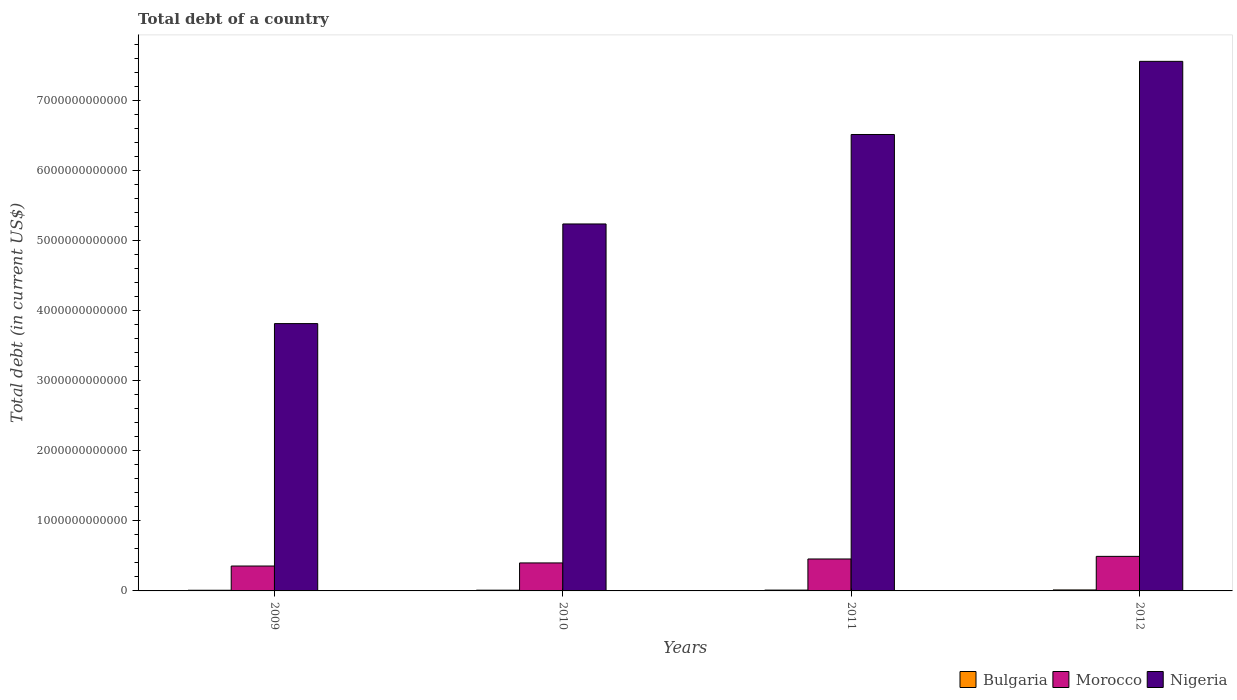How many different coloured bars are there?
Your answer should be very brief. 3. Are the number of bars on each tick of the X-axis equal?
Keep it short and to the point. Yes. How many bars are there on the 3rd tick from the left?
Your answer should be very brief. 3. How many bars are there on the 1st tick from the right?
Give a very brief answer. 3. In how many cases, is the number of bars for a given year not equal to the number of legend labels?
Ensure brevity in your answer.  0. What is the debt in Nigeria in 2012?
Keep it short and to the point. 7.56e+12. Across all years, what is the maximum debt in Morocco?
Offer a terse response. 4.94e+11. Across all years, what is the minimum debt in Morocco?
Your response must be concise. 3.56e+11. In which year was the debt in Bulgaria maximum?
Your answer should be very brief. 2012. What is the total debt in Morocco in the graph?
Provide a succinct answer. 1.71e+12. What is the difference between the debt in Nigeria in 2009 and that in 2011?
Ensure brevity in your answer.  -2.70e+12. What is the difference between the debt in Nigeria in 2010 and the debt in Bulgaria in 2009?
Your answer should be very brief. 5.23e+12. What is the average debt in Morocco per year?
Your answer should be compact. 4.26e+11. In the year 2010, what is the difference between the debt in Nigeria and debt in Morocco?
Give a very brief answer. 4.84e+12. What is the ratio of the debt in Bulgaria in 2011 to that in 2012?
Give a very brief answer. 0.83. What is the difference between the highest and the second highest debt in Bulgaria?
Provide a succinct answer. 2.40e+09. What is the difference between the highest and the lowest debt in Morocco?
Offer a very short reply. 1.38e+11. Is the sum of the debt in Morocco in 2009 and 2012 greater than the maximum debt in Nigeria across all years?
Provide a short and direct response. No. What does the 2nd bar from the left in 2009 represents?
Offer a very short reply. Morocco. How many bars are there?
Make the answer very short. 12. Are all the bars in the graph horizontal?
Your answer should be compact. No. How many years are there in the graph?
Keep it short and to the point. 4. What is the difference between two consecutive major ticks on the Y-axis?
Provide a succinct answer. 1.00e+12. Are the values on the major ticks of Y-axis written in scientific E-notation?
Your answer should be very brief. No. Does the graph contain any zero values?
Offer a terse response. No. Does the graph contain grids?
Keep it short and to the point. No. Where does the legend appear in the graph?
Your response must be concise. Bottom right. How many legend labels are there?
Provide a short and direct response. 3. What is the title of the graph?
Your answer should be very brief. Total debt of a country. Does "Mauritius" appear as one of the legend labels in the graph?
Keep it short and to the point. No. What is the label or title of the X-axis?
Provide a short and direct response. Years. What is the label or title of the Y-axis?
Your answer should be compact. Total debt (in current US$). What is the Total debt (in current US$) of Bulgaria in 2009?
Provide a succinct answer. 9.44e+09. What is the Total debt (in current US$) in Morocco in 2009?
Your answer should be compact. 3.56e+11. What is the Total debt (in current US$) in Nigeria in 2009?
Offer a very short reply. 3.82e+12. What is the Total debt (in current US$) in Bulgaria in 2010?
Ensure brevity in your answer.  1.05e+1. What is the Total debt (in current US$) of Morocco in 2010?
Keep it short and to the point. 4.00e+11. What is the Total debt (in current US$) of Nigeria in 2010?
Your answer should be compact. 5.24e+12. What is the Total debt (in current US$) in Bulgaria in 2011?
Give a very brief answer. 1.16e+1. What is the Total debt (in current US$) in Morocco in 2011?
Keep it short and to the point. 4.56e+11. What is the Total debt (in current US$) of Nigeria in 2011?
Provide a short and direct response. 6.52e+12. What is the Total debt (in current US$) of Bulgaria in 2012?
Provide a short and direct response. 1.40e+1. What is the Total debt (in current US$) in Morocco in 2012?
Your answer should be compact. 4.94e+11. What is the Total debt (in current US$) of Nigeria in 2012?
Keep it short and to the point. 7.56e+12. Across all years, what is the maximum Total debt (in current US$) of Bulgaria?
Provide a short and direct response. 1.40e+1. Across all years, what is the maximum Total debt (in current US$) in Morocco?
Your answer should be very brief. 4.94e+11. Across all years, what is the maximum Total debt (in current US$) of Nigeria?
Ensure brevity in your answer.  7.56e+12. Across all years, what is the minimum Total debt (in current US$) in Bulgaria?
Offer a terse response. 9.44e+09. Across all years, what is the minimum Total debt (in current US$) of Morocco?
Your response must be concise. 3.56e+11. Across all years, what is the minimum Total debt (in current US$) of Nigeria?
Your response must be concise. 3.82e+12. What is the total Total debt (in current US$) in Bulgaria in the graph?
Your response must be concise. 4.56e+1. What is the total Total debt (in current US$) in Morocco in the graph?
Keep it short and to the point. 1.71e+12. What is the total Total debt (in current US$) of Nigeria in the graph?
Offer a terse response. 2.31e+13. What is the difference between the Total debt (in current US$) of Bulgaria in 2009 and that in 2010?
Your answer should be compact. -1.09e+09. What is the difference between the Total debt (in current US$) in Morocco in 2009 and that in 2010?
Keep it short and to the point. -4.43e+1. What is the difference between the Total debt (in current US$) of Nigeria in 2009 and that in 2010?
Your answer should be compact. -1.42e+12. What is the difference between the Total debt (in current US$) in Bulgaria in 2009 and that in 2011?
Your response must be concise. -2.19e+09. What is the difference between the Total debt (in current US$) of Morocco in 2009 and that in 2011?
Provide a short and direct response. -1.01e+11. What is the difference between the Total debt (in current US$) in Nigeria in 2009 and that in 2011?
Your answer should be very brief. -2.70e+12. What is the difference between the Total debt (in current US$) of Bulgaria in 2009 and that in 2012?
Offer a terse response. -4.58e+09. What is the difference between the Total debt (in current US$) in Morocco in 2009 and that in 2012?
Make the answer very short. -1.38e+11. What is the difference between the Total debt (in current US$) in Nigeria in 2009 and that in 2012?
Keep it short and to the point. -3.75e+12. What is the difference between the Total debt (in current US$) in Bulgaria in 2010 and that in 2011?
Your answer should be compact. -1.10e+09. What is the difference between the Total debt (in current US$) of Morocco in 2010 and that in 2011?
Your answer should be compact. -5.63e+1. What is the difference between the Total debt (in current US$) in Nigeria in 2010 and that in 2011?
Provide a short and direct response. -1.28e+12. What is the difference between the Total debt (in current US$) of Bulgaria in 2010 and that in 2012?
Your response must be concise. -3.49e+09. What is the difference between the Total debt (in current US$) in Morocco in 2010 and that in 2012?
Your answer should be compact. -9.38e+1. What is the difference between the Total debt (in current US$) of Nigeria in 2010 and that in 2012?
Offer a terse response. -2.32e+12. What is the difference between the Total debt (in current US$) in Bulgaria in 2011 and that in 2012?
Offer a very short reply. -2.40e+09. What is the difference between the Total debt (in current US$) of Morocco in 2011 and that in 2012?
Your answer should be very brief. -3.75e+1. What is the difference between the Total debt (in current US$) of Nigeria in 2011 and that in 2012?
Your answer should be compact. -1.04e+12. What is the difference between the Total debt (in current US$) of Bulgaria in 2009 and the Total debt (in current US$) of Morocco in 2010?
Your answer should be compact. -3.90e+11. What is the difference between the Total debt (in current US$) in Bulgaria in 2009 and the Total debt (in current US$) in Nigeria in 2010?
Offer a terse response. -5.23e+12. What is the difference between the Total debt (in current US$) in Morocco in 2009 and the Total debt (in current US$) in Nigeria in 2010?
Your response must be concise. -4.89e+12. What is the difference between the Total debt (in current US$) in Bulgaria in 2009 and the Total debt (in current US$) in Morocco in 2011?
Offer a very short reply. -4.47e+11. What is the difference between the Total debt (in current US$) in Bulgaria in 2009 and the Total debt (in current US$) in Nigeria in 2011?
Ensure brevity in your answer.  -6.51e+12. What is the difference between the Total debt (in current US$) of Morocco in 2009 and the Total debt (in current US$) of Nigeria in 2011?
Offer a very short reply. -6.16e+12. What is the difference between the Total debt (in current US$) of Bulgaria in 2009 and the Total debt (in current US$) of Morocco in 2012?
Make the answer very short. -4.84e+11. What is the difference between the Total debt (in current US$) of Bulgaria in 2009 and the Total debt (in current US$) of Nigeria in 2012?
Provide a succinct answer. -7.55e+12. What is the difference between the Total debt (in current US$) in Morocco in 2009 and the Total debt (in current US$) in Nigeria in 2012?
Provide a short and direct response. -7.21e+12. What is the difference between the Total debt (in current US$) in Bulgaria in 2010 and the Total debt (in current US$) in Morocco in 2011?
Offer a very short reply. -4.46e+11. What is the difference between the Total debt (in current US$) of Bulgaria in 2010 and the Total debt (in current US$) of Nigeria in 2011?
Make the answer very short. -6.51e+12. What is the difference between the Total debt (in current US$) of Morocco in 2010 and the Total debt (in current US$) of Nigeria in 2011?
Ensure brevity in your answer.  -6.12e+12. What is the difference between the Total debt (in current US$) in Bulgaria in 2010 and the Total debt (in current US$) in Morocco in 2012?
Make the answer very short. -4.83e+11. What is the difference between the Total debt (in current US$) in Bulgaria in 2010 and the Total debt (in current US$) in Nigeria in 2012?
Offer a very short reply. -7.55e+12. What is the difference between the Total debt (in current US$) in Morocco in 2010 and the Total debt (in current US$) in Nigeria in 2012?
Make the answer very short. -7.16e+12. What is the difference between the Total debt (in current US$) of Bulgaria in 2011 and the Total debt (in current US$) of Morocco in 2012?
Offer a terse response. -4.82e+11. What is the difference between the Total debt (in current US$) of Bulgaria in 2011 and the Total debt (in current US$) of Nigeria in 2012?
Offer a very short reply. -7.55e+12. What is the difference between the Total debt (in current US$) of Morocco in 2011 and the Total debt (in current US$) of Nigeria in 2012?
Give a very brief answer. -7.11e+12. What is the average Total debt (in current US$) in Bulgaria per year?
Offer a very short reply. 1.14e+1. What is the average Total debt (in current US$) of Morocco per year?
Make the answer very short. 4.26e+11. What is the average Total debt (in current US$) in Nigeria per year?
Your answer should be compact. 5.79e+12. In the year 2009, what is the difference between the Total debt (in current US$) in Bulgaria and Total debt (in current US$) in Morocco?
Provide a short and direct response. -3.46e+11. In the year 2009, what is the difference between the Total debt (in current US$) in Bulgaria and Total debt (in current US$) in Nigeria?
Provide a short and direct response. -3.81e+12. In the year 2009, what is the difference between the Total debt (in current US$) of Morocco and Total debt (in current US$) of Nigeria?
Provide a short and direct response. -3.46e+12. In the year 2010, what is the difference between the Total debt (in current US$) in Bulgaria and Total debt (in current US$) in Morocco?
Ensure brevity in your answer.  -3.89e+11. In the year 2010, what is the difference between the Total debt (in current US$) of Bulgaria and Total debt (in current US$) of Nigeria?
Offer a terse response. -5.23e+12. In the year 2010, what is the difference between the Total debt (in current US$) in Morocco and Total debt (in current US$) in Nigeria?
Keep it short and to the point. -4.84e+12. In the year 2011, what is the difference between the Total debt (in current US$) of Bulgaria and Total debt (in current US$) of Morocco?
Give a very brief answer. -4.45e+11. In the year 2011, what is the difference between the Total debt (in current US$) of Bulgaria and Total debt (in current US$) of Nigeria?
Offer a terse response. -6.51e+12. In the year 2011, what is the difference between the Total debt (in current US$) of Morocco and Total debt (in current US$) of Nigeria?
Make the answer very short. -6.06e+12. In the year 2012, what is the difference between the Total debt (in current US$) of Bulgaria and Total debt (in current US$) of Morocco?
Keep it short and to the point. -4.80e+11. In the year 2012, what is the difference between the Total debt (in current US$) of Bulgaria and Total debt (in current US$) of Nigeria?
Make the answer very short. -7.55e+12. In the year 2012, what is the difference between the Total debt (in current US$) in Morocco and Total debt (in current US$) in Nigeria?
Keep it short and to the point. -7.07e+12. What is the ratio of the Total debt (in current US$) of Bulgaria in 2009 to that in 2010?
Your answer should be compact. 0.9. What is the ratio of the Total debt (in current US$) in Morocco in 2009 to that in 2010?
Provide a succinct answer. 0.89. What is the ratio of the Total debt (in current US$) in Nigeria in 2009 to that in 2010?
Keep it short and to the point. 0.73. What is the ratio of the Total debt (in current US$) of Bulgaria in 2009 to that in 2011?
Ensure brevity in your answer.  0.81. What is the ratio of the Total debt (in current US$) in Morocco in 2009 to that in 2011?
Offer a terse response. 0.78. What is the ratio of the Total debt (in current US$) in Nigeria in 2009 to that in 2011?
Your response must be concise. 0.59. What is the ratio of the Total debt (in current US$) of Bulgaria in 2009 to that in 2012?
Keep it short and to the point. 0.67. What is the ratio of the Total debt (in current US$) in Morocco in 2009 to that in 2012?
Ensure brevity in your answer.  0.72. What is the ratio of the Total debt (in current US$) of Nigeria in 2009 to that in 2012?
Provide a short and direct response. 0.5. What is the ratio of the Total debt (in current US$) of Bulgaria in 2010 to that in 2011?
Ensure brevity in your answer.  0.91. What is the ratio of the Total debt (in current US$) in Morocco in 2010 to that in 2011?
Give a very brief answer. 0.88. What is the ratio of the Total debt (in current US$) of Nigeria in 2010 to that in 2011?
Make the answer very short. 0.8. What is the ratio of the Total debt (in current US$) in Bulgaria in 2010 to that in 2012?
Your answer should be very brief. 0.75. What is the ratio of the Total debt (in current US$) in Morocco in 2010 to that in 2012?
Your response must be concise. 0.81. What is the ratio of the Total debt (in current US$) in Nigeria in 2010 to that in 2012?
Make the answer very short. 0.69. What is the ratio of the Total debt (in current US$) in Bulgaria in 2011 to that in 2012?
Offer a terse response. 0.83. What is the ratio of the Total debt (in current US$) in Morocco in 2011 to that in 2012?
Keep it short and to the point. 0.92. What is the ratio of the Total debt (in current US$) in Nigeria in 2011 to that in 2012?
Provide a succinct answer. 0.86. What is the difference between the highest and the second highest Total debt (in current US$) of Bulgaria?
Offer a terse response. 2.40e+09. What is the difference between the highest and the second highest Total debt (in current US$) in Morocco?
Provide a short and direct response. 3.75e+1. What is the difference between the highest and the second highest Total debt (in current US$) in Nigeria?
Ensure brevity in your answer.  1.04e+12. What is the difference between the highest and the lowest Total debt (in current US$) of Bulgaria?
Your response must be concise. 4.58e+09. What is the difference between the highest and the lowest Total debt (in current US$) of Morocco?
Your answer should be compact. 1.38e+11. What is the difference between the highest and the lowest Total debt (in current US$) in Nigeria?
Offer a terse response. 3.75e+12. 